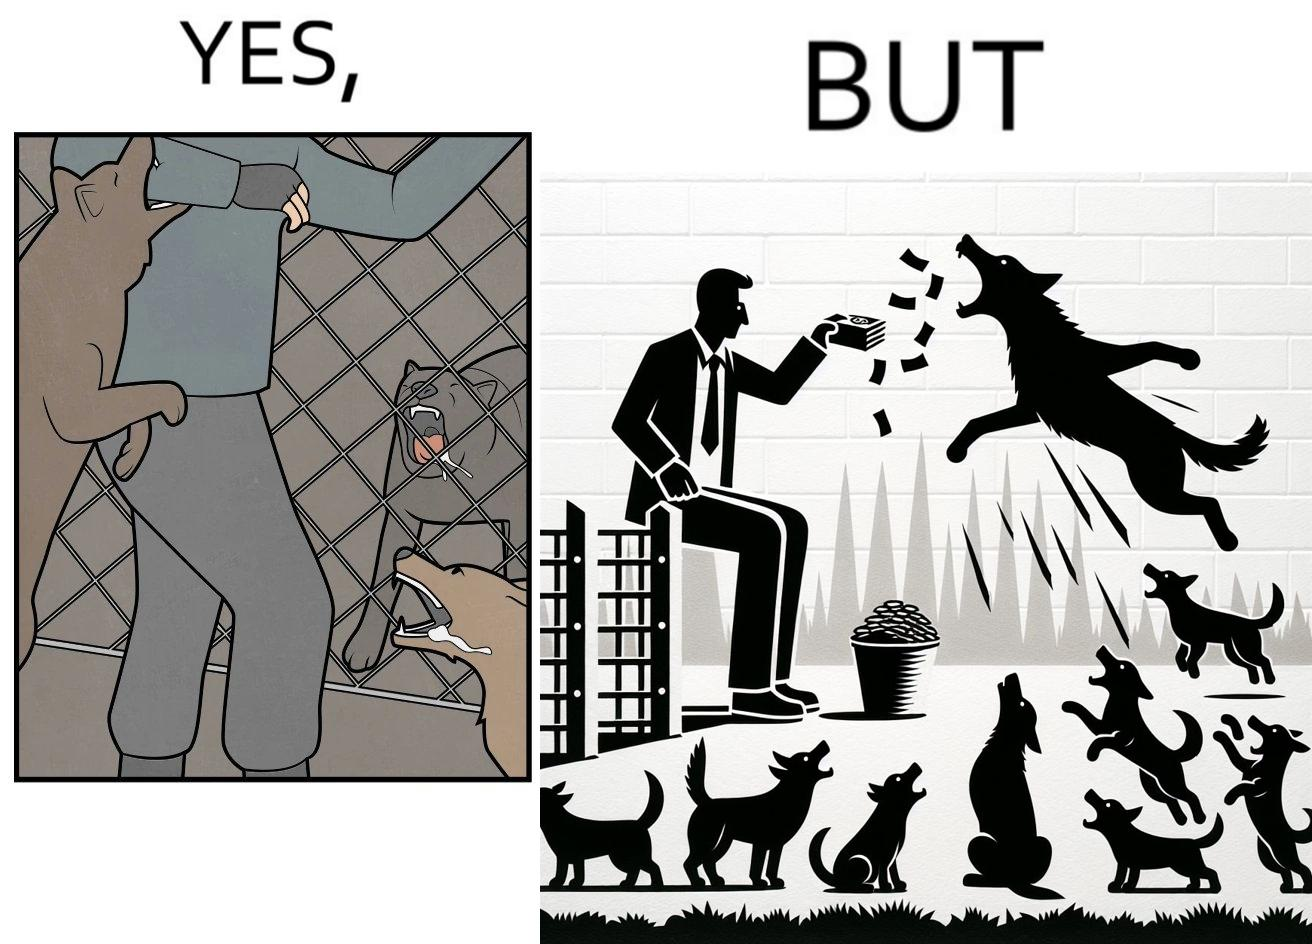Why is this image considered satirical? The images are ironic since they show how dogs choose to attack a well wisher making a donation for helping dogs. It is sad that dogs mistake a well wisher and bite him while he is trying to help them. 